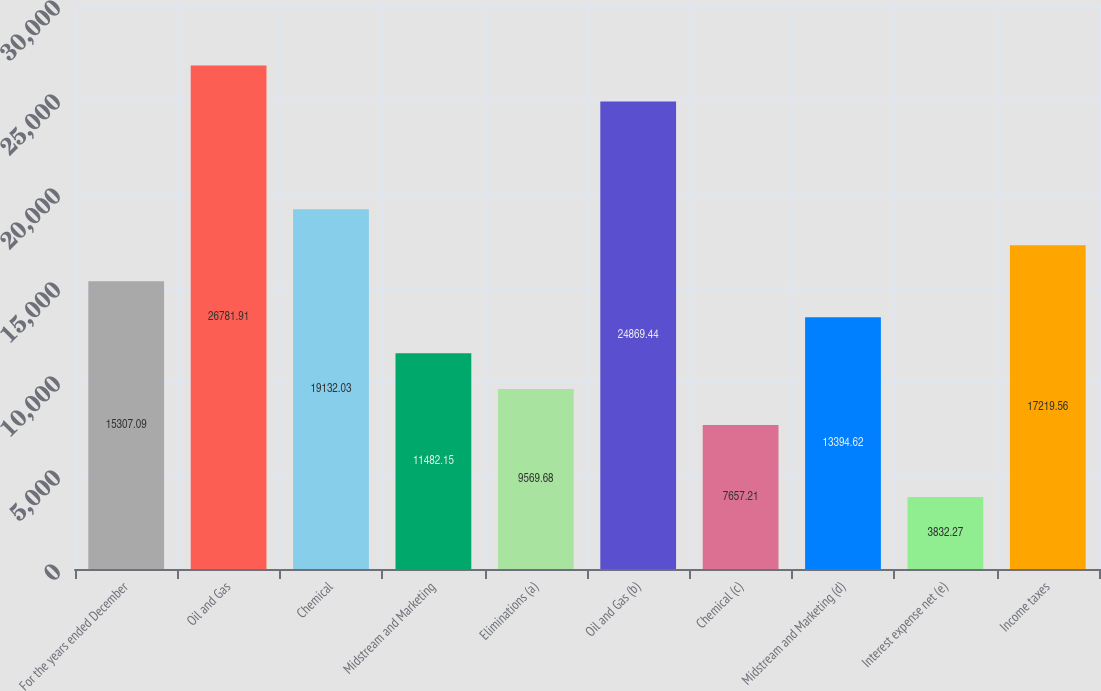Convert chart. <chart><loc_0><loc_0><loc_500><loc_500><bar_chart><fcel>For the years ended December<fcel>Oil and Gas<fcel>Chemical<fcel>Midstream and Marketing<fcel>Eliminations (a)<fcel>Oil and Gas (b)<fcel>Chemical (c)<fcel>Midstream and Marketing (d)<fcel>Interest expense net (e)<fcel>Income taxes<nl><fcel>15307.1<fcel>26781.9<fcel>19132<fcel>11482.1<fcel>9569.68<fcel>24869.4<fcel>7657.21<fcel>13394.6<fcel>3832.27<fcel>17219.6<nl></chart> 